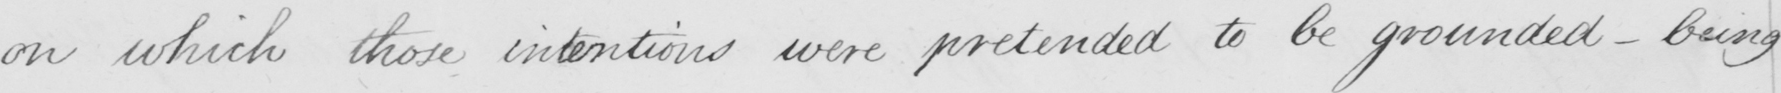What does this handwritten line say? on which those intentions were pretended to be grounded _ being 